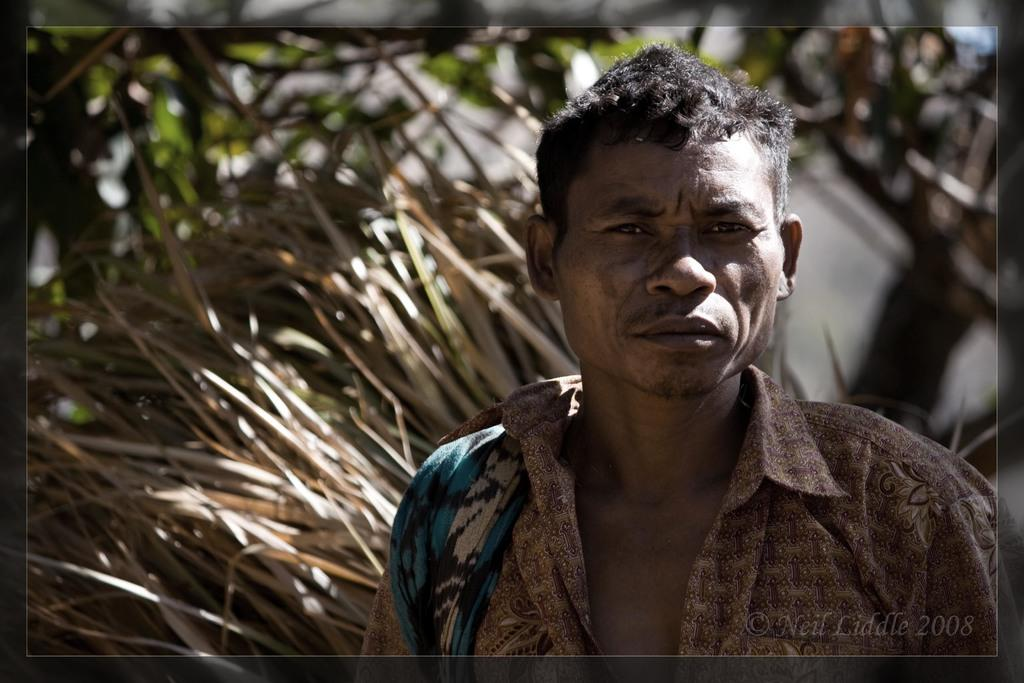Who is present on the right side of the image? There is a man on the right side of the image. What else can be found in the image besides the man? There is some text in the bottom right-hand corner of the image. How many eggs are present in the image? There are no eggs visible in the image. What type of pies can be seen in the image? There are no pies present in the image. 